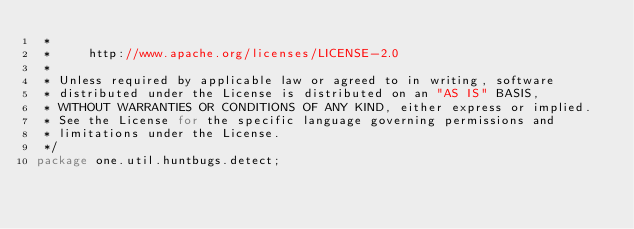Convert code to text. <code><loc_0><loc_0><loc_500><loc_500><_Java_> * 
 *     http://www.apache.org/licenses/LICENSE-2.0
 * 
 * Unless required by applicable law or agreed to in writing, software
 * distributed under the License is distributed on an "AS IS" BASIS,
 * WITHOUT WARRANTIES OR CONDITIONS OF ANY KIND, either express or implied.
 * See the License for the specific language governing permissions and
 * limitations under the License.
 */
package one.util.huntbugs.detect;
</code> 